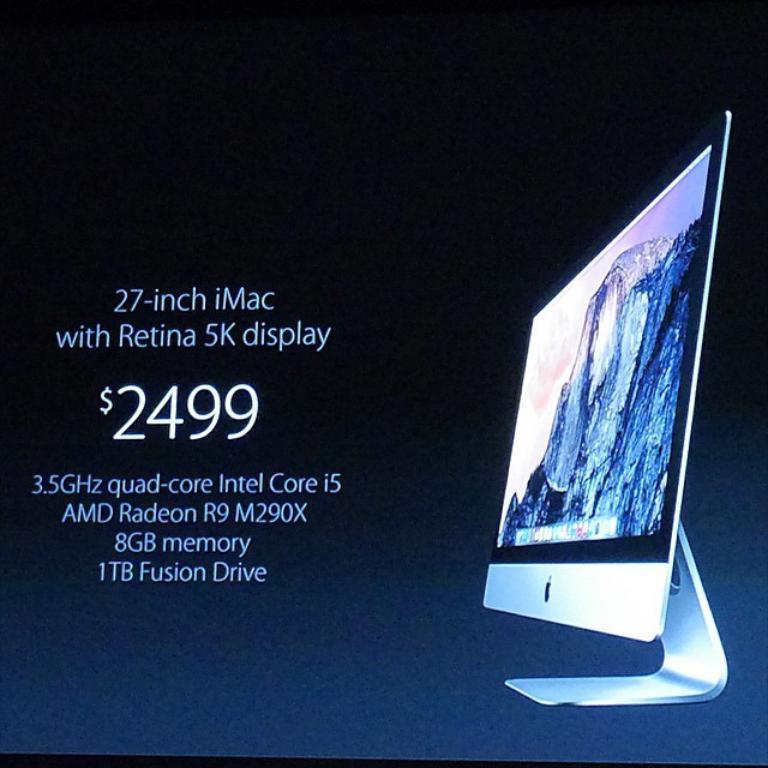How much does the 27 inch imac display cost in dollars?
Your response must be concise. 2499. 